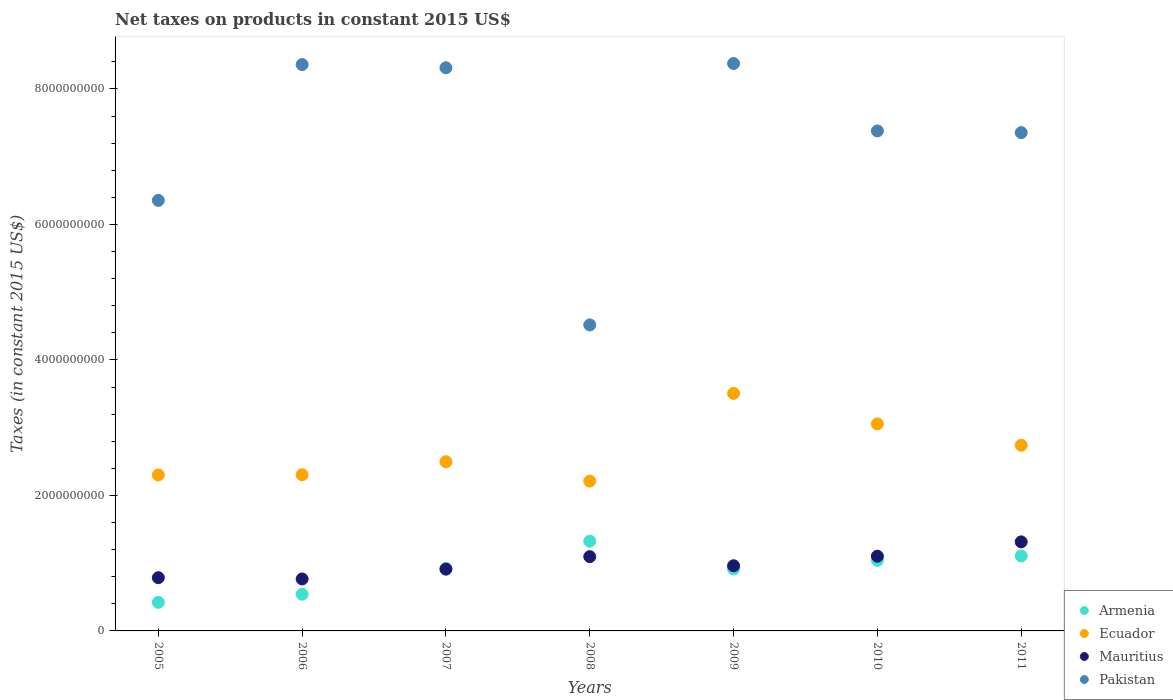Is the number of dotlines equal to the number of legend labels?
Give a very brief answer. Yes. What is the net taxes on products in Mauritius in 2007?
Provide a succinct answer. 9.12e+08. Across all years, what is the maximum net taxes on products in Mauritius?
Ensure brevity in your answer.  1.31e+09. Across all years, what is the minimum net taxes on products in Pakistan?
Ensure brevity in your answer.  4.52e+09. In which year was the net taxes on products in Mauritius maximum?
Ensure brevity in your answer.  2011. In which year was the net taxes on products in Ecuador minimum?
Provide a succinct answer. 2008. What is the total net taxes on products in Mauritius in the graph?
Provide a short and direct response. 6.94e+09. What is the difference between the net taxes on products in Armenia in 2006 and that in 2010?
Your answer should be compact. -5.00e+08. What is the difference between the net taxes on products in Armenia in 2011 and the net taxes on products in Pakistan in 2010?
Provide a succinct answer. -6.27e+09. What is the average net taxes on products in Ecuador per year?
Your answer should be very brief. 2.66e+09. In the year 2007, what is the difference between the net taxes on products in Ecuador and net taxes on products in Pakistan?
Keep it short and to the point. -5.82e+09. In how many years, is the net taxes on products in Ecuador greater than 2800000000 US$?
Provide a succinct answer. 2. What is the ratio of the net taxes on products in Ecuador in 2008 to that in 2009?
Ensure brevity in your answer.  0.63. Is the net taxes on products in Armenia in 2005 less than that in 2011?
Offer a terse response. Yes. Is the difference between the net taxes on products in Ecuador in 2005 and 2008 greater than the difference between the net taxes on products in Pakistan in 2005 and 2008?
Provide a succinct answer. No. What is the difference between the highest and the second highest net taxes on products in Armenia?
Your answer should be very brief. 2.18e+08. What is the difference between the highest and the lowest net taxes on products in Ecuador?
Your answer should be compact. 1.29e+09. In how many years, is the net taxes on products in Mauritius greater than the average net taxes on products in Mauritius taken over all years?
Keep it short and to the point. 3. How many years are there in the graph?
Offer a terse response. 7. What is the difference between two consecutive major ticks on the Y-axis?
Your answer should be very brief. 2.00e+09. Does the graph contain grids?
Give a very brief answer. No. Where does the legend appear in the graph?
Your answer should be compact. Bottom right. How are the legend labels stacked?
Your response must be concise. Vertical. What is the title of the graph?
Provide a succinct answer. Net taxes on products in constant 2015 US$. What is the label or title of the Y-axis?
Your answer should be compact. Taxes (in constant 2015 US$). What is the Taxes (in constant 2015 US$) of Armenia in 2005?
Provide a short and direct response. 4.21e+08. What is the Taxes (in constant 2015 US$) in Ecuador in 2005?
Provide a short and direct response. 2.30e+09. What is the Taxes (in constant 2015 US$) of Mauritius in 2005?
Offer a terse response. 7.86e+08. What is the Taxes (in constant 2015 US$) of Pakistan in 2005?
Provide a succinct answer. 6.35e+09. What is the Taxes (in constant 2015 US$) of Armenia in 2006?
Make the answer very short. 5.42e+08. What is the Taxes (in constant 2015 US$) of Ecuador in 2006?
Your answer should be very brief. 2.30e+09. What is the Taxes (in constant 2015 US$) in Mauritius in 2006?
Make the answer very short. 7.67e+08. What is the Taxes (in constant 2015 US$) in Pakistan in 2006?
Provide a short and direct response. 8.36e+09. What is the Taxes (in constant 2015 US$) of Armenia in 2007?
Provide a short and direct response. 9.22e+08. What is the Taxes (in constant 2015 US$) in Ecuador in 2007?
Provide a short and direct response. 2.50e+09. What is the Taxes (in constant 2015 US$) of Mauritius in 2007?
Offer a terse response. 9.12e+08. What is the Taxes (in constant 2015 US$) in Pakistan in 2007?
Your response must be concise. 8.31e+09. What is the Taxes (in constant 2015 US$) in Armenia in 2008?
Make the answer very short. 1.32e+09. What is the Taxes (in constant 2015 US$) in Ecuador in 2008?
Ensure brevity in your answer.  2.21e+09. What is the Taxes (in constant 2015 US$) of Mauritius in 2008?
Offer a very short reply. 1.10e+09. What is the Taxes (in constant 2015 US$) of Pakistan in 2008?
Your answer should be compact. 4.52e+09. What is the Taxes (in constant 2015 US$) in Armenia in 2009?
Your answer should be compact. 9.15e+08. What is the Taxes (in constant 2015 US$) of Ecuador in 2009?
Offer a terse response. 3.51e+09. What is the Taxes (in constant 2015 US$) in Mauritius in 2009?
Offer a very short reply. 9.62e+08. What is the Taxes (in constant 2015 US$) in Pakistan in 2009?
Give a very brief answer. 8.38e+09. What is the Taxes (in constant 2015 US$) in Armenia in 2010?
Your answer should be compact. 1.04e+09. What is the Taxes (in constant 2015 US$) in Ecuador in 2010?
Ensure brevity in your answer.  3.06e+09. What is the Taxes (in constant 2015 US$) in Mauritius in 2010?
Your answer should be very brief. 1.10e+09. What is the Taxes (in constant 2015 US$) of Pakistan in 2010?
Ensure brevity in your answer.  7.38e+09. What is the Taxes (in constant 2015 US$) in Armenia in 2011?
Offer a terse response. 1.11e+09. What is the Taxes (in constant 2015 US$) of Ecuador in 2011?
Offer a terse response. 2.74e+09. What is the Taxes (in constant 2015 US$) in Mauritius in 2011?
Offer a very short reply. 1.31e+09. What is the Taxes (in constant 2015 US$) in Pakistan in 2011?
Keep it short and to the point. 7.36e+09. Across all years, what is the maximum Taxes (in constant 2015 US$) in Armenia?
Make the answer very short. 1.32e+09. Across all years, what is the maximum Taxes (in constant 2015 US$) in Ecuador?
Offer a terse response. 3.51e+09. Across all years, what is the maximum Taxes (in constant 2015 US$) of Mauritius?
Offer a very short reply. 1.31e+09. Across all years, what is the maximum Taxes (in constant 2015 US$) of Pakistan?
Keep it short and to the point. 8.38e+09. Across all years, what is the minimum Taxes (in constant 2015 US$) in Armenia?
Offer a very short reply. 4.21e+08. Across all years, what is the minimum Taxes (in constant 2015 US$) of Ecuador?
Offer a terse response. 2.21e+09. Across all years, what is the minimum Taxes (in constant 2015 US$) in Mauritius?
Provide a short and direct response. 7.67e+08. Across all years, what is the minimum Taxes (in constant 2015 US$) of Pakistan?
Keep it short and to the point. 4.52e+09. What is the total Taxes (in constant 2015 US$) of Armenia in the graph?
Your response must be concise. 6.27e+09. What is the total Taxes (in constant 2015 US$) of Ecuador in the graph?
Offer a terse response. 1.86e+1. What is the total Taxes (in constant 2015 US$) in Mauritius in the graph?
Your answer should be very brief. 6.94e+09. What is the total Taxes (in constant 2015 US$) of Pakistan in the graph?
Provide a short and direct response. 5.07e+1. What is the difference between the Taxes (in constant 2015 US$) of Armenia in 2005 and that in 2006?
Keep it short and to the point. -1.20e+08. What is the difference between the Taxes (in constant 2015 US$) in Ecuador in 2005 and that in 2006?
Your answer should be very brief. -2.96e+06. What is the difference between the Taxes (in constant 2015 US$) of Mauritius in 2005 and that in 2006?
Your answer should be very brief. 1.88e+07. What is the difference between the Taxes (in constant 2015 US$) of Pakistan in 2005 and that in 2006?
Keep it short and to the point. -2.00e+09. What is the difference between the Taxes (in constant 2015 US$) in Armenia in 2005 and that in 2007?
Provide a short and direct response. -5.01e+08. What is the difference between the Taxes (in constant 2015 US$) of Ecuador in 2005 and that in 2007?
Your response must be concise. -1.95e+08. What is the difference between the Taxes (in constant 2015 US$) of Mauritius in 2005 and that in 2007?
Your response must be concise. -1.26e+08. What is the difference between the Taxes (in constant 2015 US$) of Pakistan in 2005 and that in 2007?
Keep it short and to the point. -1.96e+09. What is the difference between the Taxes (in constant 2015 US$) in Armenia in 2005 and that in 2008?
Offer a very short reply. -9.03e+08. What is the difference between the Taxes (in constant 2015 US$) in Ecuador in 2005 and that in 2008?
Your answer should be very brief. 9.02e+07. What is the difference between the Taxes (in constant 2015 US$) in Mauritius in 2005 and that in 2008?
Make the answer very short. -3.11e+08. What is the difference between the Taxes (in constant 2015 US$) of Pakistan in 2005 and that in 2008?
Offer a terse response. 1.84e+09. What is the difference between the Taxes (in constant 2015 US$) in Armenia in 2005 and that in 2009?
Provide a succinct answer. -4.94e+08. What is the difference between the Taxes (in constant 2015 US$) of Ecuador in 2005 and that in 2009?
Ensure brevity in your answer.  -1.20e+09. What is the difference between the Taxes (in constant 2015 US$) in Mauritius in 2005 and that in 2009?
Give a very brief answer. -1.76e+08. What is the difference between the Taxes (in constant 2015 US$) in Pakistan in 2005 and that in 2009?
Your response must be concise. -2.02e+09. What is the difference between the Taxes (in constant 2015 US$) of Armenia in 2005 and that in 2010?
Offer a terse response. -6.20e+08. What is the difference between the Taxes (in constant 2015 US$) of Ecuador in 2005 and that in 2010?
Provide a short and direct response. -7.54e+08. What is the difference between the Taxes (in constant 2015 US$) of Mauritius in 2005 and that in 2010?
Your response must be concise. -3.17e+08. What is the difference between the Taxes (in constant 2015 US$) of Pakistan in 2005 and that in 2010?
Provide a short and direct response. -1.02e+09. What is the difference between the Taxes (in constant 2015 US$) of Armenia in 2005 and that in 2011?
Offer a very short reply. -6.86e+08. What is the difference between the Taxes (in constant 2015 US$) in Ecuador in 2005 and that in 2011?
Offer a very short reply. -4.39e+08. What is the difference between the Taxes (in constant 2015 US$) in Mauritius in 2005 and that in 2011?
Offer a terse response. -5.29e+08. What is the difference between the Taxes (in constant 2015 US$) of Pakistan in 2005 and that in 2011?
Provide a short and direct response. -1.00e+09. What is the difference between the Taxes (in constant 2015 US$) in Armenia in 2006 and that in 2007?
Offer a very short reply. -3.81e+08. What is the difference between the Taxes (in constant 2015 US$) in Ecuador in 2006 and that in 2007?
Make the answer very short. -1.92e+08. What is the difference between the Taxes (in constant 2015 US$) in Mauritius in 2006 and that in 2007?
Your answer should be compact. -1.45e+08. What is the difference between the Taxes (in constant 2015 US$) of Pakistan in 2006 and that in 2007?
Make the answer very short. 4.72e+07. What is the difference between the Taxes (in constant 2015 US$) in Armenia in 2006 and that in 2008?
Make the answer very short. -7.83e+08. What is the difference between the Taxes (in constant 2015 US$) of Ecuador in 2006 and that in 2008?
Give a very brief answer. 9.32e+07. What is the difference between the Taxes (in constant 2015 US$) of Mauritius in 2006 and that in 2008?
Offer a very short reply. -3.30e+08. What is the difference between the Taxes (in constant 2015 US$) in Pakistan in 2006 and that in 2008?
Provide a succinct answer. 3.84e+09. What is the difference between the Taxes (in constant 2015 US$) in Armenia in 2006 and that in 2009?
Make the answer very short. -3.74e+08. What is the difference between the Taxes (in constant 2015 US$) in Ecuador in 2006 and that in 2009?
Your response must be concise. -1.20e+09. What is the difference between the Taxes (in constant 2015 US$) in Mauritius in 2006 and that in 2009?
Make the answer very short. -1.95e+08. What is the difference between the Taxes (in constant 2015 US$) in Pakistan in 2006 and that in 2009?
Keep it short and to the point. -1.55e+07. What is the difference between the Taxes (in constant 2015 US$) in Armenia in 2006 and that in 2010?
Provide a short and direct response. -5.00e+08. What is the difference between the Taxes (in constant 2015 US$) of Ecuador in 2006 and that in 2010?
Your response must be concise. -7.51e+08. What is the difference between the Taxes (in constant 2015 US$) of Mauritius in 2006 and that in 2010?
Your answer should be compact. -3.36e+08. What is the difference between the Taxes (in constant 2015 US$) of Pakistan in 2006 and that in 2010?
Your response must be concise. 9.80e+08. What is the difference between the Taxes (in constant 2015 US$) of Armenia in 2006 and that in 2011?
Offer a terse response. -5.65e+08. What is the difference between the Taxes (in constant 2015 US$) in Ecuador in 2006 and that in 2011?
Offer a very short reply. -4.36e+08. What is the difference between the Taxes (in constant 2015 US$) in Mauritius in 2006 and that in 2011?
Your answer should be very brief. -5.47e+08. What is the difference between the Taxes (in constant 2015 US$) of Pakistan in 2006 and that in 2011?
Give a very brief answer. 1.00e+09. What is the difference between the Taxes (in constant 2015 US$) of Armenia in 2007 and that in 2008?
Offer a very short reply. -4.02e+08. What is the difference between the Taxes (in constant 2015 US$) in Ecuador in 2007 and that in 2008?
Offer a terse response. 2.85e+08. What is the difference between the Taxes (in constant 2015 US$) in Mauritius in 2007 and that in 2008?
Your answer should be compact. -1.85e+08. What is the difference between the Taxes (in constant 2015 US$) of Pakistan in 2007 and that in 2008?
Make the answer very short. 3.80e+09. What is the difference between the Taxes (in constant 2015 US$) of Armenia in 2007 and that in 2009?
Keep it short and to the point. 7.03e+06. What is the difference between the Taxes (in constant 2015 US$) of Ecuador in 2007 and that in 2009?
Offer a terse response. -1.01e+09. What is the difference between the Taxes (in constant 2015 US$) of Mauritius in 2007 and that in 2009?
Your answer should be very brief. -5.01e+07. What is the difference between the Taxes (in constant 2015 US$) of Pakistan in 2007 and that in 2009?
Provide a short and direct response. -6.28e+07. What is the difference between the Taxes (in constant 2015 US$) in Armenia in 2007 and that in 2010?
Give a very brief answer. -1.19e+08. What is the difference between the Taxes (in constant 2015 US$) in Ecuador in 2007 and that in 2010?
Provide a succinct answer. -5.59e+08. What is the difference between the Taxes (in constant 2015 US$) of Mauritius in 2007 and that in 2010?
Your answer should be very brief. -1.91e+08. What is the difference between the Taxes (in constant 2015 US$) of Pakistan in 2007 and that in 2010?
Your answer should be very brief. 9.33e+08. What is the difference between the Taxes (in constant 2015 US$) in Armenia in 2007 and that in 2011?
Make the answer very short. -1.84e+08. What is the difference between the Taxes (in constant 2015 US$) of Ecuador in 2007 and that in 2011?
Provide a short and direct response. -2.44e+08. What is the difference between the Taxes (in constant 2015 US$) in Mauritius in 2007 and that in 2011?
Make the answer very short. -4.03e+08. What is the difference between the Taxes (in constant 2015 US$) of Pakistan in 2007 and that in 2011?
Keep it short and to the point. 9.57e+08. What is the difference between the Taxes (in constant 2015 US$) of Armenia in 2008 and that in 2009?
Provide a short and direct response. 4.09e+08. What is the difference between the Taxes (in constant 2015 US$) of Ecuador in 2008 and that in 2009?
Give a very brief answer. -1.29e+09. What is the difference between the Taxes (in constant 2015 US$) in Mauritius in 2008 and that in 2009?
Make the answer very short. 1.35e+08. What is the difference between the Taxes (in constant 2015 US$) of Pakistan in 2008 and that in 2009?
Ensure brevity in your answer.  -3.86e+09. What is the difference between the Taxes (in constant 2015 US$) in Armenia in 2008 and that in 2010?
Offer a terse response. 2.83e+08. What is the difference between the Taxes (in constant 2015 US$) of Ecuador in 2008 and that in 2010?
Offer a very short reply. -8.44e+08. What is the difference between the Taxes (in constant 2015 US$) in Mauritius in 2008 and that in 2010?
Make the answer very short. -6.44e+06. What is the difference between the Taxes (in constant 2015 US$) in Pakistan in 2008 and that in 2010?
Ensure brevity in your answer.  -2.86e+09. What is the difference between the Taxes (in constant 2015 US$) of Armenia in 2008 and that in 2011?
Your answer should be very brief. 2.18e+08. What is the difference between the Taxes (in constant 2015 US$) of Ecuador in 2008 and that in 2011?
Your response must be concise. -5.29e+08. What is the difference between the Taxes (in constant 2015 US$) of Mauritius in 2008 and that in 2011?
Keep it short and to the point. -2.18e+08. What is the difference between the Taxes (in constant 2015 US$) of Pakistan in 2008 and that in 2011?
Your response must be concise. -2.84e+09. What is the difference between the Taxes (in constant 2015 US$) in Armenia in 2009 and that in 2010?
Offer a very short reply. -1.26e+08. What is the difference between the Taxes (in constant 2015 US$) of Ecuador in 2009 and that in 2010?
Keep it short and to the point. 4.51e+08. What is the difference between the Taxes (in constant 2015 US$) in Mauritius in 2009 and that in 2010?
Make the answer very short. -1.41e+08. What is the difference between the Taxes (in constant 2015 US$) in Pakistan in 2009 and that in 2010?
Provide a succinct answer. 9.95e+08. What is the difference between the Taxes (in constant 2015 US$) in Armenia in 2009 and that in 2011?
Offer a very short reply. -1.91e+08. What is the difference between the Taxes (in constant 2015 US$) of Ecuador in 2009 and that in 2011?
Your response must be concise. 7.66e+08. What is the difference between the Taxes (in constant 2015 US$) of Mauritius in 2009 and that in 2011?
Your answer should be compact. -3.53e+08. What is the difference between the Taxes (in constant 2015 US$) of Pakistan in 2009 and that in 2011?
Your response must be concise. 1.02e+09. What is the difference between the Taxes (in constant 2015 US$) in Armenia in 2010 and that in 2011?
Provide a succinct answer. -6.55e+07. What is the difference between the Taxes (in constant 2015 US$) in Ecuador in 2010 and that in 2011?
Give a very brief answer. 3.15e+08. What is the difference between the Taxes (in constant 2015 US$) in Mauritius in 2010 and that in 2011?
Offer a very short reply. -2.11e+08. What is the difference between the Taxes (in constant 2015 US$) of Pakistan in 2010 and that in 2011?
Your answer should be very brief. 2.47e+07. What is the difference between the Taxes (in constant 2015 US$) in Armenia in 2005 and the Taxes (in constant 2015 US$) in Ecuador in 2006?
Keep it short and to the point. -1.88e+09. What is the difference between the Taxes (in constant 2015 US$) in Armenia in 2005 and the Taxes (in constant 2015 US$) in Mauritius in 2006?
Provide a short and direct response. -3.46e+08. What is the difference between the Taxes (in constant 2015 US$) of Armenia in 2005 and the Taxes (in constant 2015 US$) of Pakistan in 2006?
Ensure brevity in your answer.  -7.94e+09. What is the difference between the Taxes (in constant 2015 US$) in Ecuador in 2005 and the Taxes (in constant 2015 US$) in Mauritius in 2006?
Provide a short and direct response. 1.53e+09. What is the difference between the Taxes (in constant 2015 US$) of Ecuador in 2005 and the Taxes (in constant 2015 US$) of Pakistan in 2006?
Provide a succinct answer. -6.06e+09. What is the difference between the Taxes (in constant 2015 US$) in Mauritius in 2005 and the Taxes (in constant 2015 US$) in Pakistan in 2006?
Make the answer very short. -7.57e+09. What is the difference between the Taxes (in constant 2015 US$) of Armenia in 2005 and the Taxes (in constant 2015 US$) of Ecuador in 2007?
Your answer should be compact. -2.08e+09. What is the difference between the Taxes (in constant 2015 US$) of Armenia in 2005 and the Taxes (in constant 2015 US$) of Mauritius in 2007?
Your answer should be compact. -4.90e+08. What is the difference between the Taxes (in constant 2015 US$) in Armenia in 2005 and the Taxes (in constant 2015 US$) in Pakistan in 2007?
Your answer should be very brief. -7.89e+09. What is the difference between the Taxes (in constant 2015 US$) in Ecuador in 2005 and the Taxes (in constant 2015 US$) in Mauritius in 2007?
Make the answer very short. 1.39e+09. What is the difference between the Taxes (in constant 2015 US$) of Ecuador in 2005 and the Taxes (in constant 2015 US$) of Pakistan in 2007?
Provide a short and direct response. -6.01e+09. What is the difference between the Taxes (in constant 2015 US$) of Mauritius in 2005 and the Taxes (in constant 2015 US$) of Pakistan in 2007?
Offer a very short reply. -7.53e+09. What is the difference between the Taxes (in constant 2015 US$) in Armenia in 2005 and the Taxes (in constant 2015 US$) in Ecuador in 2008?
Keep it short and to the point. -1.79e+09. What is the difference between the Taxes (in constant 2015 US$) in Armenia in 2005 and the Taxes (in constant 2015 US$) in Mauritius in 2008?
Provide a succinct answer. -6.75e+08. What is the difference between the Taxes (in constant 2015 US$) in Armenia in 2005 and the Taxes (in constant 2015 US$) in Pakistan in 2008?
Provide a short and direct response. -4.10e+09. What is the difference between the Taxes (in constant 2015 US$) of Ecuador in 2005 and the Taxes (in constant 2015 US$) of Mauritius in 2008?
Make the answer very short. 1.21e+09. What is the difference between the Taxes (in constant 2015 US$) of Ecuador in 2005 and the Taxes (in constant 2015 US$) of Pakistan in 2008?
Your response must be concise. -2.21e+09. What is the difference between the Taxes (in constant 2015 US$) of Mauritius in 2005 and the Taxes (in constant 2015 US$) of Pakistan in 2008?
Make the answer very short. -3.73e+09. What is the difference between the Taxes (in constant 2015 US$) of Armenia in 2005 and the Taxes (in constant 2015 US$) of Ecuador in 2009?
Offer a terse response. -3.09e+09. What is the difference between the Taxes (in constant 2015 US$) in Armenia in 2005 and the Taxes (in constant 2015 US$) in Mauritius in 2009?
Give a very brief answer. -5.40e+08. What is the difference between the Taxes (in constant 2015 US$) of Armenia in 2005 and the Taxes (in constant 2015 US$) of Pakistan in 2009?
Your response must be concise. -7.95e+09. What is the difference between the Taxes (in constant 2015 US$) in Ecuador in 2005 and the Taxes (in constant 2015 US$) in Mauritius in 2009?
Give a very brief answer. 1.34e+09. What is the difference between the Taxes (in constant 2015 US$) in Ecuador in 2005 and the Taxes (in constant 2015 US$) in Pakistan in 2009?
Your answer should be very brief. -6.07e+09. What is the difference between the Taxes (in constant 2015 US$) in Mauritius in 2005 and the Taxes (in constant 2015 US$) in Pakistan in 2009?
Offer a terse response. -7.59e+09. What is the difference between the Taxes (in constant 2015 US$) of Armenia in 2005 and the Taxes (in constant 2015 US$) of Ecuador in 2010?
Your response must be concise. -2.63e+09. What is the difference between the Taxes (in constant 2015 US$) in Armenia in 2005 and the Taxes (in constant 2015 US$) in Mauritius in 2010?
Give a very brief answer. -6.82e+08. What is the difference between the Taxes (in constant 2015 US$) in Armenia in 2005 and the Taxes (in constant 2015 US$) in Pakistan in 2010?
Your answer should be compact. -6.96e+09. What is the difference between the Taxes (in constant 2015 US$) in Ecuador in 2005 and the Taxes (in constant 2015 US$) in Mauritius in 2010?
Offer a very short reply. 1.20e+09. What is the difference between the Taxes (in constant 2015 US$) of Ecuador in 2005 and the Taxes (in constant 2015 US$) of Pakistan in 2010?
Keep it short and to the point. -5.08e+09. What is the difference between the Taxes (in constant 2015 US$) in Mauritius in 2005 and the Taxes (in constant 2015 US$) in Pakistan in 2010?
Provide a short and direct response. -6.59e+09. What is the difference between the Taxes (in constant 2015 US$) in Armenia in 2005 and the Taxes (in constant 2015 US$) in Ecuador in 2011?
Ensure brevity in your answer.  -2.32e+09. What is the difference between the Taxes (in constant 2015 US$) in Armenia in 2005 and the Taxes (in constant 2015 US$) in Mauritius in 2011?
Provide a short and direct response. -8.93e+08. What is the difference between the Taxes (in constant 2015 US$) of Armenia in 2005 and the Taxes (in constant 2015 US$) of Pakistan in 2011?
Give a very brief answer. -6.93e+09. What is the difference between the Taxes (in constant 2015 US$) of Ecuador in 2005 and the Taxes (in constant 2015 US$) of Mauritius in 2011?
Ensure brevity in your answer.  9.88e+08. What is the difference between the Taxes (in constant 2015 US$) of Ecuador in 2005 and the Taxes (in constant 2015 US$) of Pakistan in 2011?
Offer a very short reply. -5.05e+09. What is the difference between the Taxes (in constant 2015 US$) in Mauritius in 2005 and the Taxes (in constant 2015 US$) in Pakistan in 2011?
Ensure brevity in your answer.  -6.57e+09. What is the difference between the Taxes (in constant 2015 US$) of Armenia in 2006 and the Taxes (in constant 2015 US$) of Ecuador in 2007?
Make the answer very short. -1.96e+09. What is the difference between the Taxes (in constant 2015 US$) of Armenia in 2006 and the Taxes (in constant 2015 US$) of Mauritius in 2007?
Offer a terse response. -3.70e+08. What is the difference between the Taxes (in constant 2015 US$) of Armenia in 2006 and the Taxes (in constant 2015 US$) of Pakistan in 2007?
Your response must be concise. -7.77e+09. What is the difference between the Taxes (in constant 2015 US$) of Ecuador in 2006 and the Taxes (in constant 2015 US$) of Mauritius in 2007?
Ensure brevity in your answer.  1.39e+09. What is the difference between the Taxes (in constant 2015 US$) in Ecuador in 2006 and the Taxes (in constant 2015 US$) in Pakistan in 2007?
Your answer should be very brief. -6.01e+09. What is the difference between the Taxes (in constant 2015 US$) in Mauritius in 2006 and the Taxes (in constant 2015 US$) in Pakistan in 2007?
Give a very brief answer. -7.55e+09. What is the difference between the Taxes (in constant 2015 US$) in Armenia in 2006 and the Taxes (in constant 2015 US$) in Ecuador in 2008?
Ensure brevity in your answer.  -1.67e+09. What is the difference between the Taxes (in constant 2015 US$) of Armenia in 2006 and the Taxes (in constant 2015 US$) of Mauritius in 2008?
Make the answer very short. -5.55e+08. What is the difference between the Taxes (in constant 2015 US$) in Armenia in 2006 and the Taxes (in constant 2015 US$) in Pakistan in 2008?
Make the answer very short. -3.98e+09. What is the difference between the Taxes (in constant 2015 US$) in Ecuador in 2006 and the Taxes (in constant 2015 US$) in Mauritius in 2008?
Offer a very short reply. 1.21e+09. What is the difference between the Taxes (in constant 2015 US$) of Ecuador in 2006 and the Taxes (in constant 2015 US$) of Pakistan in 2008?
Your response must be concise. -2.21e+09. What is the difference between the Taxes (in constant 2015 US$) of Mauritius in 2006 and the Taxes (in constant 2015 US$) of Pakistan in 2008?
Provide a succinct answer. -3.75e+09. What is the difference between the Taxes (in constant 2015 US$) of Armenia in 2006 and the Taxes (in constant 2015 US$) of Ecuador in 2009?
Ensure brevity in your answer.  -2.96e+09. What is the difference between the Taxes (in constant 2015 US$) in Armenia in 2006 and the Taxes (in constant 2015 US$) in Mauritius in 2009?
Ensure brevity in your answer.  -4.20e+08. What is the difference between the Taxes (in constant 2015 US$) of Armenia in 2006 and the Taxes (in constant 2015 US$) of Pakistan in 2009?
Offer a terse response. -7.83e+09. What is the difference between the Taxes (in constant 2015 US$) in Ecuador in 2006 and the Taxes (in constant 2015 US$) in Mauritius in 2009?
Offer a very short reply. 1.34e+09. What is the difference between the Taxes (in constant 2015 US$) of Ecuador in 2006 and the Taxes (in constant 2015 US$) of Pakistan in 2009?
Your answer should be very brief. -6.07e+09. What is the difference between the Taxes (in constant 2015 US$) in Mauritius in 2006 and the Taxes (in constant 2015 US$) in Pakistan in 2009?
Keep it short and to the point. -7.61e+09. What is the difference between the Taxes (in constant 2015 US$) of Armenia in 2006 and the Taxes (in constant 2015 US$) of Ecuador in 2010?
Provide a succinct answer. -2.51e+09. What is the difference between the Taxes (in constant 2015 US$) in Armenia in 2006 and the Taxes (in constant 2015 US$) in Mauritius in 2010?
Offer a terse response. -5.61e+08. What is the difference between the Taxes (in constant 2015 US$) of Armenia in 2006 and the Taxes (in constant 2015 US$) of Pakistan in 2010?
Keep it short and to the point. -6.84e+09. What is the difference between the Taxes (in constant 2015 US$) in Ecuador in 2006 and the Taxes (in constant 2015 US$) in Mauritius in 2010?
Make the answer very short. 1.20e+09. What is the difference between the Taxes (in constant 2015 US$) in Ecuador in 2006 and the Taxes (in constant 2015 US$) in Pakistan in 2010?
Give a very brief answer. -5.08e+09. What is the difference between the Taxes (in constant 2015 US$) of Mauritius in 2006 and the Taxes (in constant 2015 US$) of Pakistan in 2010?
Keep it short and to the point. -6.61e+09. What is the difference between the Taxes (in constant 2015 US$) of Armenia in 2006 and the Taxes (in constant 2015 US$) of Ecuador in 2011?
Ensure brevity in your answer.  -2.20e+09. What is the difference between the Taxes (in constant 2015 US$) in Armenia in 2006 and the Taxes (in constant 2015 US$) in Mauritius in 2011?
Your response must be concise. -7.73e+08. What is the difference between the Taxes (in constant 2015 US$) in Armenia in 2006 and the Taxes (in constant 2015 US$) in Pakistan in 2011?
Your response must be concise. -6.81e+09. What is the difference between the Taxes (in constant 2015 US$) in Ecuador in 2006 and the Taxes (in constant 2015 US$) in Mauritius in 2011?
Ensure brevity in your answer.  9.91e+08. What is the difference between the Taxes (in constant 2015 US$) of Ecuador in 2006 and the Taxes (in constant 2015 US$) of Pakistan in 2011?
Give a very brief answer. -5.05e+09. What is the difference between the Taxes (in constant 2015 US$) in Mauritius in 2006 and the Taxes (in constant 2015 US$) in Pakistan in 2011?
Provide a short and direct response. -6.59e+09. What is the difference between the Taxes (in constant 2015 US$) of Armenia in 2007 and the Taxes (in constant 2015 US$) of Ecuador in 2008?
Offer a very short reply. -1.29e+09. What is the difference between the Taxes (in constant 2015 US$) in Armenia in 2007 and the Taxes (in constant 2015 US$) in Mauritius in 2008?
Your answer should be compact. -1.74e+08. What is the difference between the Taxes (in constant 2015 US$) in Armenia in 2007 and the Taxes (in constant 2015 US$) in Pakistan in 2008?
Keep it short and to the point. -3.59e+09. What is the difference between the Taxes (in constant 2015 US$) in Ecuador in 2007 and the Taxes (in constant 2015 US$) in Mauritius in 2008?
Keep it short and to the point. 1.40e+09. What is the difference between the Taxes (in constant 2015 US$) of Ecuador in 2007 and the Taxes (in constant 2015 US$) of Pakistan in 2008?
Your answer should be very brief. -2.02e+09. What is the difference between the Taxes (in constant 2015 US$) in Mauritius in 2007 and the Taxes (in constant 2015 US$) in Pakistan in 2008?
Give a very brief answer. -3.61e+09. What is the difference between the Taxes (in constant 2015 US$) in Armenia in 2007 and the Taxes (in constant 2015 US$) in Ecuador in 2009?
Your response must be concise. -2.58e+09. What is the difference between the Taxes (in constant 2015 US$) of Armenia in 2007 and the Taxes (in constant 2015 US$) of Mauritius in 2009?
Ensure brevity in your answer.  -3.94e+07. What is the difference between the Taxes (in constant 2015 US$) in Armenia in 2007 and the Taxes (in constant 2015 US$) in Pakistan in 2009?
Provide a short and direct response. -7.45e+09. What is the difference between the Taxes (in constant 2015 US$) of Ecuador in 2007 and the Taxes (in constant 2015 US$) of Mauritius in 2009?
Ensure brevity in your answer.  1.54e+09. What is the difference between the Taxes (in constant 2015 US$) in Ecuador in 2007 and the Taxes (in constant 2015 US$) in Pakistan in 2009?
Make the answer very short. -5.88e+09. What is the difference between the Taxes (in constant 2015 US$) in Mauritius in 2007 and the Taxes (in constant 2015 US$) in Pakistan in 2009?
Your answer should be very brief. -7.46e+09. What is the difference between the Taxes (in constant 2015 US$) of Armenia in 2007 and the Taxes (in constant 2015 US$) of Ecuador in 2010?
Provide a short and direct response. -2.13e+09. What is the difference between the Taxes (in constant 2015 US$) of Armenia in 2007 and the Taxes (in constant 2015 US$) of Mauritius in 2010?
Give a very brief answer. -1.81e+08. What is the difference between the Taxes (in constant 2015 US$) in Armenia in 2007 and the Taxes (in constant 2015 US$) in Pakistan in 2010?
Your answer should be very brief. -6.46e+09. What is the difference between the Taxes (in constant 2015 US$) of Ecuador in 2007 and the Taxes (in constant 2015 US$) of Mauritius in 2010?
Offer a very short reply. 1.39e+09. What is the difference between the Taxes (in constant 2015 US$) of Ecuador in 2007 and the Taxes (in constant 2015 US$) of Pakistan in 2010?
Your response must be concise. -4.88e+09. What is the difference between the Taxes (in constant 2015 US$) in Mauritius in 2007 and the Taxes (in constant 2015 US$) in Pakistan in 2010?
Your answer should be very brief. -6.47e+09. What is the difference between the Taxes (in constant 2015 US$) of Armenia in 2007 and the Taxes (in constant 2015 US$) of Ecuador in 2011?
Your answer should be very brief. -1.82e+09. What is the difference between the Taxes (in constant 2015 US$) of Armenia in 2007 and the Taxes (in constant 2015 US$) of Mauritius in 2011?
Make the answer very short. -3.92e+08. What is the difference between the Taxes (in constant 2015 US$) of Armenia in 2007 and the Taxes (in constant 2015 US$) of Pakistan in 2011?
Make the answer very short. -6.43e+09. What is the difference between the Taxes (in constant 2015 US$) of Ecuador in 2007 and the Taxes (in constant 2015 US$) of Mauritius in 2011?
Your response must be concise. 1.18e+09. What is the difference between the Taxes (in constant 2015 US$) in Ecuador in 2007 and the Taxes (in constant 2015 US$) in Pakistan in 2011?
Offer a very short reply. -4.86e+09. What is the difference between the Taxes (in constant 2015 US$) in Mauritius in 2007 and the Taxes (in constant 2015 US$) in Pakistan in 2011?
Offer a terse response. -6.44e+09. What is the difference between the Taxes (in constant 2015 US$) in Armenia in 2008 and the Taxes (in constant 2015 US$) in Ecuador in 2009?
Offer a very short reply. -2.18e+09. What is the difference between the Taxes (in constant 2015 US$) in Armenia in 2008 and the Taxes (in constant 2015 US$) in Mauritius in 2009?
Your answer should be very brief. 3.63e+08. What is the difference between the Taxes (in constant 2015 US$) of Armenia in 2008 and the Taxes (in constant 2015 US$) of Pakistan in 2009?
Give a very brief answer. -7.05e+09. What is the difference between the Taxes (in constant 2015 US$) in Ecuador in 2008 and the Taxes (in constant 2015 US$) in Mauritius in 2009?
Ensure brevity in your answer.  1.25e+09. What is the difference between the Taxes (in constant 2015 US$) of Ecuador in 2008 and the Taxes (in constant 2015 US$) of Pakistan in 2009?
Your answer should be compact. -6.16e+09. What is the difference between the Taxes (in constant 2015 US$) in Mauritius in 2008 and the Taxes (in constant 2015 US$) in Pakistan in 2009?
Your answer should be very brief. -7.28e+09. What is the difference between the Taxes (in constant 2015 US$) in Armenia in 2008 and the Taxes (in constant 2015 US$) in Ecuador in 2010?
Your response must be concise. -1.73e+09. What is the difference between the Taxes (in constant 2015 US$) of Armenia in 2008 and the Taxes (in constant 2015 US$) of Mauritius in 2010?
Provide a succinct answer. 2.22e+08. What is the difference between the Taxes (in constant 2015 US$) of Armenia in 2008 and the Taxes (in constant 2015 US$) of Pakistan in 2010?
Your answer should be compact. -6.06e+09. What is the difference between the Taxes (in constant 2015 US$) in Ecuador in 2008 and the Taxes (in constant 2015 US$) in Mauritius in 2010?
Offer a very short reply. 1.11e+09. What is the difference between the Taxes (in constant 2015 US$) of Ecuador in 2008 and the Taxes (in constant 2015 US$) of Pakistan in 2010?
Ensure brevity in your answer.  -5.17e+09. What is the difference between the Taxes (in constant 2015 US$) in Mauritius in 2008 and the Taxes (in constant 2015 US$) in Pakistan in 2010?
Keep it short and to the point. -6.28e+09. What is the difference between the Taxes (in constant 2015 US$) in Armenia in 2008 and the Taxes (in constant 2015 US$) in Ecuador in 2011?
Provide a short and direct response. -1.42e+09. What is the difference between the Taxes (in constant 2015 US$) of Armenia in 2008 and the Taxes (in constant 2015 US$) of Mauritius in 2011?
Keep it short and to the point. 1.02e+07. What is the difference between the Taxes (in constant 2015 US$) of Armenia in 2008 and the Taxes (in constant 2015 US$) of Pakistan in 2011?
Ensure brevity in your answer.  -6.03e+09. What is the difference between the Taxes (in constant 2015 US$) in Ecuador in 2008 and the Taxes (in constant 2015 US$) in Mauritius in 2011?
Offer a very short reply. 8.97e+08. What is the difference between the Taxes (in constant 2015 US$) in Ecuador in 2008 and the Taxes (in constant 2015 US$) in Pakistan in 2011?
Give a very brief answer. -5.14e+09. What is the difference between the Taxes (in constant 2015 US$) in Mauritius in 2008 and the Taxes (in constant 2015 US$) in Pakistan in 2011?
Your answer should be very brief. -6.26e+09. What is the difference between the Taxes (in constant 2015 US$) in Armenia in 2009 and the Taxes (in constant 2015 US$) in Ecuador in 2010?
Your response must be concise. -2.14e+09. What is the difference between the Taxes (in constant 2015 US$) of Armenia in 2009 and the Taxes (in constant 2015 US$) of Mauritius in 2010?
Provide a succinct answer. -1.88e+08. What is the difference between the Taxes (in constant 2015 US$) in Armenia in 2009 and the Taxes (in constant 2015 US$) in Pakistan in 2010?
Your answer should be very brief. -6.46e+09. What is the difference between the Taxes (in constant 2015 US$) of Ecuador in 2009 and the Taxes (in constant 2015 US$) of Mauritius in 2010?
Your answer should be very brief. 2.40e+09. What is the difference between the Taxes (in constant 2015 US$) in Ecuador in 2009 and the Taxes (in constant 2015 US$) in Pakistan in 2010?
Give a very brief answer. -3.87e+09. What is the difference between the Taxes (in constant 2015 US$) of Mauritius in 2009 and the Taxes (in constant 2015 US$) of Pakistan in 2010?
Provide a short and direct response. -6.42e+09. What is the difference between the Taxes (in constant 2015 US$) of Armenia in 2009 and the Taxes (in constant 2015 US$) of Ecuador in 2011?
Your answer should be very brief. -1.83e+09. What is the difference between the Taxes (in constant 2015 US$) of Armenia in 2009 and the Taxes (in constant 2015 US$) of Mauritius in 2011?
Provide a succinct answer. -3.99e+08. What is the difference between the Taxes (in constant 2015 US$) in Armenia in 2009 and the Taxes (in constant 2015 US$) in Pakistan in 2011?
Your answer should be compact. -6.44e+09. What is the difference between the Taxes (in constant 2015 US$) of Ecuador in 2009 and the Taxes (in constant 2015 US$) of Mauritius in 2011?
Give a very brief answer. 2.19e+09. What is the difference between the Taxes (in constant 2015 US$) of Ecuador in 2009 and the Taxes (in constant 2015 US$) of Pakistan in 2011?
Provide a short and direct response. -3.85e+09. What is the difference between the Taxes (in constant 2015 US$) of Mauritius in 2009 and the Taxes (in constant 2015 US$) of Pakistan in 2011?
Provide a succinct answer. -6.39e+09. What is the difference between the Taxes (in constant 2015 US$) in Armenia in 2010 and the Taxes (in constant 2015 US$) in Ecuador in 2011?
Keep it short and to the point. -1.70e+09. What is the difference between the Taxes (in constant 2015 US$) in Armenia in 2010 and the Taxes (in constant 2015 US$) in Mauritius in 2011?
Make the answer very short. -2.73e+08. What is the difference between the Taxes (in constant 2015 US$) in Armenia in 2010 and the Taxes (in constant 2015 US$) in Pakistan in 2011?
Offer a very short reply. -6.31e+09. What is the difference between the Taxes (in constant 2015 US$) in Ecuador in 2010 and the Taxes (in constant 2015 US$) in Mauritius in 2011?
Keep it short and to the point. 1.74e+09. What is the difference between the Taxes (in constant 2015 US$) in Ecuador in 2010 and the Taxes (in constant 2015 US$) in Pakistan in 2011?
Offer a very short reply. -4.30e+09. What is the difference between the Taxes (in constant 2015 US$) in Mauritius in 2010 and the Taxes (in constant 2015 US$) in Pakistan in 2011?
Your response must be concise. -6.25e+09. What is the average Taxes (in constant 2015 US$) of Armenia per year?
Your answer should be compact. 8.96e+08. What is the average Taxes (in constant 2015 US$) in Ecuador per year?
Ensure brevity in your answer.  2.66e+09. What is the average Taxes (in constant 2015 US$) in Mauritius per year?
Ensure brevity in your answer.  9.91e+08. What is the average Taxes (in constant 2015 US$) of Pakistan per year?
Keep it short and to the point. 7.24e+09. In the year 2005, what is the difference between the Taxes (in constant 2015 US$) in Armenia and Taxes (in constant 2015 US$) in Ecuador?
Offer a very short reply. -1.88e+09. In the year 2005, what is the difference between the Taxes (in constant 2015 US$) in Armenia and Taxes (in constant 2015 US$) in Mauritius?
Your answer should be very brief. -3.64e+08. In the year 2005, what is the difference between the Taxes (in constant 2015 US$) of Armenia and Taxes (in constant 2015 US$) of Pakistan?
Make the answer very short. -5.93e+09. In the year 2005, what is the difference between the Taxes (in constant 2015 US$) of Ecuador and Taxes (in constant 2015 US$) of Mauritius?
Provide a short and direct response. 1.52e+09. In the year 2005, what is the difference between the Taxes (in constant 2015 US$) of Ecuador and Taxes (in constant 2015 US$) of Pakistan?
Ensure brevity in your answer.  -4.05e+09. In the year 2005, what is the difference between the Taxes (in constant 2015 US$) of Mauritius and Taxes (in constant 2015 US$) of Pakistan?
Make the answer very short. -5.57e+09. In the year 2006, what is the difference between the Taxes (in constant 2015 US$) of Armenia and Taxes (in constant 2015 US$) of Ecuador?
Offer a very short reply. -1.76e+09. In the year 2006, what is the difference between the Taxes (in constant 2015 US$) of Armenia and Taxes (in constant 2015 US$) of Mauritius?
Offer a very short reply. -2.25e+08. In the year 2006, what is the difference between the Taxes (in constant 2015 US$) in Armenia and Taxes (in constant 2015 US$) in Pakistan?
Make the answer very short. -7.82e+09. In the year 2006, what is the difference between the Taxes (in constant 2015 US$) in Ecuador and Taxes (in constant 2015 US$) in Mauritius?
Ensure brevity in your answer.  1.54e+09. In the year 2006, what is the difference between the Taxes (in constant 2015 US$) in Ecuador and Taxes (in constant 2015 US$) in Pakistan?
Provide a short and direct response. -6.05e+09. In the year 2006, what is the difference between the Taxes (in constant 2015 US$) of Mauritius and Taxes (in constant 2015 US$) of Pakistan?
Keep it short and to the point. -7.59e+09. In the year 2007, what is the difference between the Taxes (in constant 2015 US$) in Armenia and Taxes (in constant 2015 US$) in Ecuador?
Keep it short and to the point. -1.57e+09. In the year 2007, what is the difference between the Taxes (in constant 2015 US$) in Armenia and Taxes (in constant 2015 US$) in Mauritius?
Ensure brevity in your answer.  1.07e+07. In the year 2007, what is the difference between the Taxes (in constant 2015 US$) in Armenia and Taxes (in constant 2015 US$) in Pakistan?
Your answer should be compact. -7.39e+09. In the year 2007, what is the difference between the Taxes (in constant 2015 US$) of Ecuador and Taxes (in constant 2015 US$) of Mauritius?
Offer a very short reply. 1.59e+09. In the year 2007, what is the difference between the Taxes (in constant 2015 US$) of Ecuador and Taxes (in constant 2015 US$) of Pakistan?
Provide a succinct answer. -5.82e+09. In the year 2007, what is the difference between the Taxes (in constant 2015 US$) of Mauritius and Taxes (in constant 2015 US$) of Pakistan?
Offer a terse response. -7.40e+09. In the year 2008, what is the difference between the Taxes (in constant 2015 US$) of Armenia and Taxes (in constant 2015 US$) of Ecuador?
Offer a terse response. -8.87e+08. In the year 2008, what is the difference between the Taxes (in constant 2015 US$) in Armenia and Taxes (in constant 2015 US$) in Mauritius?
Your answer should be very brief. 2.28e+08. In the year 2008, what is the difference between the Taxes (in constant 2015 US$) of Armenia and Taxes (in constant 2015 US$) of Pakistan?
Your answer should be very brief. -3.19e+09. In the year 2008, what is the difference between the Taxes (in constant 2015 US$) of Ecuador and Taxes (in constant 2015 US$) of Mauritius?
Provide a succinct answer. 1.12e+09. In the year 2008, what is the difference between the Taxes (in constant 2015 US$) in Ecuador and Taxes (in constant 2015 US$) in Pakistan?
Offer a very short reply. -2.31e+09. In the year 2008, what is the difference between the Taxes (in constant 2015 US$) of Mauritius and Taxes (in constant 2015 US$) of Pakistan?
Ensure brevity in your answer.  -3.42e+09. In the year 2009, what is the difference between the Taxes (in constant 2015 US$) of Armenia and Taxes (in constant 2015 US$) of Ecuador?
Provide a succinct answer. -2.59e+09. In the year 2009, what is the difference between the Taxes (in constant 2015 US$) in Armenia and Taxes (in constant 2015 US$) in Mauritius?
Your response must be concise. -4.64e+07. In the year 2009, what is the difference between the Taxes (in constant 2015 US$) in Armenia and Taxes (in constant 2015 US$) in Pakistan?
Provide a succinct answer. -7.46e+09. In the year 2009, what is the difference between the Taxes (in constant 2015 US$) of Ecuador and Taxes (in constant 2015 US$) of Mauritius?
Give a very brief answer. 2.54e+09. In the year 2009, what is the difference between the Taxes (in constant 2015 US$) in Ecuador and Taxes (in constant 2015 US$) in Pakistan?
Your answer should be compact. -4.87e+09. In the year 2009, what is the difference between the Taxes (in constant 2015 US$) in Mauritius and Taxes (in constant 2015 US$) in Pakistan?
Make the answer very short. -7.41e+09. In the year 2010, what is the difference between the Taxes (in constant 2015 US$) in Armenia and Taxes (in constant 2015 US$) in Ecuador?
Provide a short and direct response. -2.01e+09. In the year 2010, what is the difference between the Taxes (in constant 2015 US$) in Armenia and Taxes (in constant 2015 US$) in Mauritius?
Your answer should be very brief. -6.16e+07. In the year 2010, what is the difference between the Taxes (in constant 2015 US$) of Armenia and Taxes (in constant 2015 US$) of Pakistan?
Your response must be concise. -6.34e+09. In the year 2010, what is the difference between the Taxes (in constant 2015 US$) of Ecuador and Taxes (in constant 2015 US$) of Mauritius?
Offer a terse response. 1.95e+09. In the year 2010, what is the difference between the Taxes (in constant 2015 US$) in Ecuador and Taxes (in constant 2015 US$) in Pakistan?
Keep it short and to the point. -4.32e+09. In the year 2010, what is the difference between the Taxes (in constant 2015 US$) of Mauritius and Taxes (in constant 2015 US$) of Pakistan?
Ensure brevity in your answer.  -6.28e+09. In the year 2011, what is the difference between the Taxes (in constant 2015 US$) of Armenia and Taxes (in constant 2015 US$) of Ecuador?
Your answer should be compact. -1.63e+09. In the year 2011, what is the difference between the Taxes (in constant 2015 US$) of Armenia and Taxes (in constant 2015 US$) of Mauritius?
Offer a terse response. -2.07e+08. In the year 2011, what is the difference between the Taxes (in constant 2015 US$) of Armenia and Taxes (in constant 2015 US$) of Pakistan?
Provide a short and direct response. -6.25e+09. In the year 2011, what is the difference between the Taxes (in constant 2015 US$) of Ecuador and Taxes (in constant 2015 US$) of Mauritius?
Your answer should be very brief. 1.43e+09. In the year 2011, what is the difference between the Taxes (in constant 2015 US$) of Ecuador and Taxes (in constant 2015 US$) of Pakistan?
Your answer should be very brief. -4.61e+09. In the year 2011, what is the difference between the Taxes (in constant 2015 US$) in Mauritius and Taxes (in constant 2015 US$) in Pakistan?
Give a very brief answer. -6.04e+09. What is the ratio of the Taxes (in constant 2015 US$) in Armenia in 2005 to that in 2006?
Provide a short and direct response. 0.78. What is the ratio of the Taxes (in constant 2015 US$) in Mauritius in 2005 to that in 2006?
Offer a terse response. 1.02. What is the ratio of the Taxes (in constant 2015 US$) of Pakistan in 2005 to that in 2006?
Your answer should be compact. 0.76. What is the ratio of the Taxes (in constant 2015 US$) in Armenia in 2005 to that in 2007?
Provide a short and direct response. 0.46. What is the ratio of the Taxes (in constant 2015 US$) in Ecuador in 2005 to that in 2007?
Offer a terse response. 0.92. What is the ratio of the Taxes (in constant 2015 US$) in Mauritius in 2005 to that in 2007?
Make the answer very short. 0.86. What is the ratio of the Taxes (in constant 2015 US$) in Pakistan in 2005 to that in 2007?
Offer a terse response. 0.76. What is the ratio of the Taxes (in constant 2015 US$) of Armenia in 2005 to that in 2008?
Your response must be concise. 0.32. What is the ratio of the Taxes (in constant 2015 US$) in Ecuador in 2005 to that in 2008?
Your answer should be very brief. 1.04. What is the ratio of the Taxes (in constant 2015 US$) of Mauritius in 2005 to that in 2008?
Make the answer very short. 0.72. What is the ratio of the Taxes (in constant 2015 US$) in Pakistan in 2005 to that in 2008?
Keep it short and to the point. 1.41. What is the ratio of the Taxes (in constant 2015 US$) in Armenia in 2005 to that in 2009?
Provide a short and direct response. 0.46. What is the ratio of the Taxes (in constant 2015 US$) in Ecuador in 2005 to that in 2009?
Offer a terse response. 0.66. What is the ratio of the Taxes (in constant 2015 US$) of Mauritius in 2005 to that in 2009?
Your answer should be very brief. 0.82. What is the ratio of the Taxes (in constant 2015 US$) of Pakistan in 2005 to that in 2009?
Provide a short and direct response. 0.76. What is the ratio of the Taxes (in constant 2015 US$) of Armenia in 2005 to that in 2010?
Your response must be concise. 0.4. What is the ratio of the Taxes (in constant 2015 US$) of Ecuador in 2005 to that in 2010?
Provide a succinct answer. 0.75. What is the ratio of the Taxes (in constant 2015 US$) of Mauritius in 2005 to that in 2010?
Your answer should be compact. 0.71. What is the ratio of the Taxes (in constant 2015 US$) of Pakistan in 2005 to that in 2010?
Your answer should be very brief. 0.86. What is the ratio of the Taxes (in constant 2015 US$) of Armenia in 2005 to that in 2011?
Provide a succinct answer. 0.38. What is the ratio of the Taxes (in constant 2015 US$) of Ecuador in 2005 to that in 2011?
Your response must be concise. 0.84. What is the ratio of the Taxes (in constant 2015 US$) in Mauritius in 2005 to that in 2011?
Your answer should be very brief. 0.6. What is the ratio of the Taxes (in constant 2015 US$) in Pakistan in 2005 to that in 2011?
Offer a terse response. 0.86. What is the ratio of the Taxes (in constant 2015 US$) of Armenia in 2006 to that in 2007?
Your response must be concise. 0.59. What is the ratio of the Taxes (in constant 2015 US$) in Mauritius in 2006 to that in 2007?
Your answer should be very brief. 0.84. What is the ratio of the Taxes (in constant 2015 US$) in Armenia in 2006 to that in 2008?
Give a very brief answer. 0.41. What is the ratio of the Taxes (in constant 2015 US$) in Ecuador in 2006 to that in 2008?
Ensure brevity in your answer.  1.04. What is the ratio of the Taxes (in constant 2015 US$) of Mauritius in 2006 to that in 2008?
Give a very brief answer. 0.7. What is the ratio of the Taxes (in constant 2015 US$) in Pakistan in 2006 to that in 2008?
Provide a succinct answer. 1.85. What is the ratio of the Taxes (in constant 2015 US$) in Armenia in 2006 to that in 2009?
Keep it short and to the point. 0.59. What is the ratio of the Taxes (in constant 2015 US$) of Ecuador in 2006 to that in 2009?
Your answer should be very brief. 0.66. What is the ratio of the Taxes (in constant 2015 US$) in Mauritius in 2006 to that in 2009?
Make the answer very short. 0.8. What is the ratio of the Taxes (in constant 2015 US$) in Pakistan in 2006 to that in 2009?
Give a very brief answer. 1. What is the ratio of the Taxes (in constant 2015 US$) in Armenia in 2006 to that in 2010?
Your answer should be compact. 0.52. What is the ratio of the Taxes (in constant 2015 US$) of Ecuador in 2006 to that in 2010?
Keep it short and to the point. 0.75. What is the ratio of the Taxes (in constant 2015 US$) in Mauritius in 2006 to that in 2010?
Your response must be concise. 0.7. What is the ratio of the Taxes (in constant 2015 US$) of Pakistan in 2006 to that in 2010?
Provide a short and direct response. 1.13. What is the ratio of the Taxes (in constant 2015 US$) of Armenia in 2006 to that in 2011?
Offer a terse response. 0.49. What is the ratio of the Taxes (in constant 2015 US$) in Ecuador in 2006 to that in 2011?
Provide a succinct answer. 0.84. What is the ratio of the Taxes (in constant 2015 US$) of Mauritius in 2006 to that in 2011?
Give a very brief answer. 0.58. What is the ratio of the Taxes (in constant 2015 US$) in Pakistan in 2006 to that in 2011?
Your response must be concise. 1.14. What is the ratio of the Taxes (in constant 2015 US$) of Armenia in 2007 to that in 2008?
Make the answer very short. 0.7. What is the ratio of the Taxes (in constant 2015 US$) of Ecuador in 2007 to that in 2008?
Provide a succinct answer. 1.13. What is the ratio of the Taxes (in constant 2015 US$) in Mauritius in 2007 to that in 2008?
Offer a very short reply. 0.83. What is the ratio of the Taxes (in constant 2015 US$) in Pakistan in 2007 to that in 2008?
Your answer should be very brief. 1.84. What is the ratio of the Taxes (in constant 2015 US$) of Armenia in 2007 to that in 2009?
Give a very brief answer. 1.01. What is the ratio of the Taxes (in constant 2015 US$) in Ecuador in 2007 to that in 2009?
Your response must be concise. 0.71. What is the ratio of the Taxes (in constant 2015 US$) of Mauritius in 2007 to that in 2009?
Make the answer very short. 0.95. What is the ratio of the Taxes (in constant 2015 US$) in Pakistan in 2007 to that in 2009?
Ensure brevity in your answer.  0.99. What is the ratio of the Taxes (in constant 2015 US$) of Armenia in 2007 to that in 2010?
Make the answer very short. 0.89. What is the ratio of the Taxes (in constant 2015 US$) in Ecuador in 2007 to that in 2010?
Offer a very short reply. 0.82. What is the ratio of the Taxes (in constant 2015 US$) of Mauritius in 2007 to that in 2010?
Offer a terse response. 0.83. What is the ratio of the Taxes (in constant 2015 US$) of Pakistan in 2007 to that in 2010?
Your answer should be compact. 1.13. What is the ratio of the Taxes (in constant 2015 US$) in Armenia in 2007 to that in 2011?
Offer a very short reply. 0.83. What is the ratio of the Taxes (in constant 2015 US$) in Ecuador in 2007 to that in 2011?
Offer a terse response. 0.91. What is the ratio of the Taxes (in constant 2015 US$) in Mauritius in 2007 to that in 2011?
Your answer should be compact. 0.69. What is the ratio of the Taxes (in constant 2015 US$) in Pakistan in 2007 to that in 2011?
Provide a succinct answer. 1.13. What is the ratio of the Taxes (in constant 2015 US$) of Armenia in 2008 to that in 2009?
Your response must be concise. 1.45. What is the ratio of the Taxes (in constant 2015 US$) of Ecuador in 2008 to that in 2009?
Provide a short and direct response. 0.63. What is the ratio of the Taxes (in constant 2015 US$) of Mauritius in 2008 to that in 2009?
Your answer should be very brief. 1.14. What is the ratio of the Taxes (in constant 2015 US$) in Pakistan in 2008 to that in 2009?
Offer a very short reply. 0.54. What is the ratio of the Taxes (in constant 2015 US$) in Armenia in 2008 to that in 2010?
Give a very brief answer. 1.27. What is the ratio of the Taxes (in constant 2015 US$) in Ecuador in 2008 to that in 2010?
Give a very brief answer. 0.72. What is the ratio of the Taxes (in constant 2015 US$) of Pakistan in 2008 to that in 2010?
Give a very brief answer. 0.61. What is the ratio of the Taxes (in constant 2015 US$) of Armenia in 2008 to that in 2011?
Offer a terse response. 1.2. What is the ratio of the Taxes (in constant 2015 US$) in Ecuador in 2008 to that in 2011?
Your answer should be compact. 0.81. What is the ratio of the Taxes (in constant 2015 US$) of Mauritius in 2008 to that in 2011?
Provide a short and direct response. 0.83. What is the ratio of the Taxes (in constant 2015 US$) of Pakistan in 2008 to that in 2011?
Give a very brief answer. 0.61. What is the ratio of the Taxes (in constant 2015 US$) of Armenia in 2009 to that in 2010?
Ensure brevity in your answer.  0.88. What is the ratio of the Taxes (in constant 2015 US$) in Ecuador in 2009 to that in 2010?
Ensure brevity in your answer.  1.15. What is the ratio of the Taxes (in constant 2015 US$) of Mauritius in 2009 to that in 2010?
Your answer should be compact. 0.87. What is the ratio of the Taxes (in constant 2015 US$) in Pakistan in 2009 to that in 2010?
Provide a short and direct response. 1.13. What is the ratio of the Taxes (in constant 2015 US$) in Armenia in 2009 to that in 2011?
Your answer should be compact. 0.83. What is the ratio of the Taxes (in constant 2015 US$) of Ecuador in 2009 to that in 2011?
Provide a succinct answer. 1.28. What is the ratio of the Taxes (in constant 2015 US$) of Mauritius in 2009 to that in 2011?
Keep it short and to the point. 0.73. What is the ratio of the Taxes (in constant 2015 US$) of Pakistan in 2009 to that in 2011?
Ensure brevity in your answer.  1.14. What is the ratio of the Taxes (in constant 2015 US$) in Armenia in 2010 to that in 2011?
Give a very brief answer. 0.94. What is the ratio of the Taxes (in constant 2015 US$) in Ecuador in 2010 to that in 2011?
Your answer should be compact. 1.12. What is the ratio of the Taxes (in constant 2015 US$) in Mauritius in 2010 to that in 2011?
Provide a short and direct response. 0.84. What is the ratio of the Taxes (in constant 2015 US$) of Pakistan in 2010 to that in 2011?
Your answer should be very brief. 1. What is the difference between the highest and the second highest Taxes (in constant 2015 US$) in Armenia?
Give a very brief answer. 2.18e+08. What is the difference between the highest and the second highest Taxes (in constant 2015 US$) of Ecuador?
Offer a terse response. 4.51e+08. What is the difference between the highest and the second highest Taxes (in constant 2015 US$) of Mauritius?
Provide a succinct answer. 2.11e+08. What is the difference between the highest and the second highest Taxes (in constant 2015 US$) of Pakistan?
Keep it short and to the point. 1.55e+07. What is the difference between the highest and the lowest Taxes (in constant 2015 US$) of Armenia?
Offer a very short reply. 9.03e+08. What is the difference between the highest and the lowest Taxes (in constant 2015 US$) of Ecuador?
Provide a succinct answer. 1.29e+09. What is the difference between the highest and the lowest Taxes (in constant 2015 US$) of Mauritius?
Make the answer very short. 5.47e+08. What is the difference between the highest and the lowest Taxes (in constant 2015 US$) in Pakistan?
Your answer should be compact. 3.86e+09. 